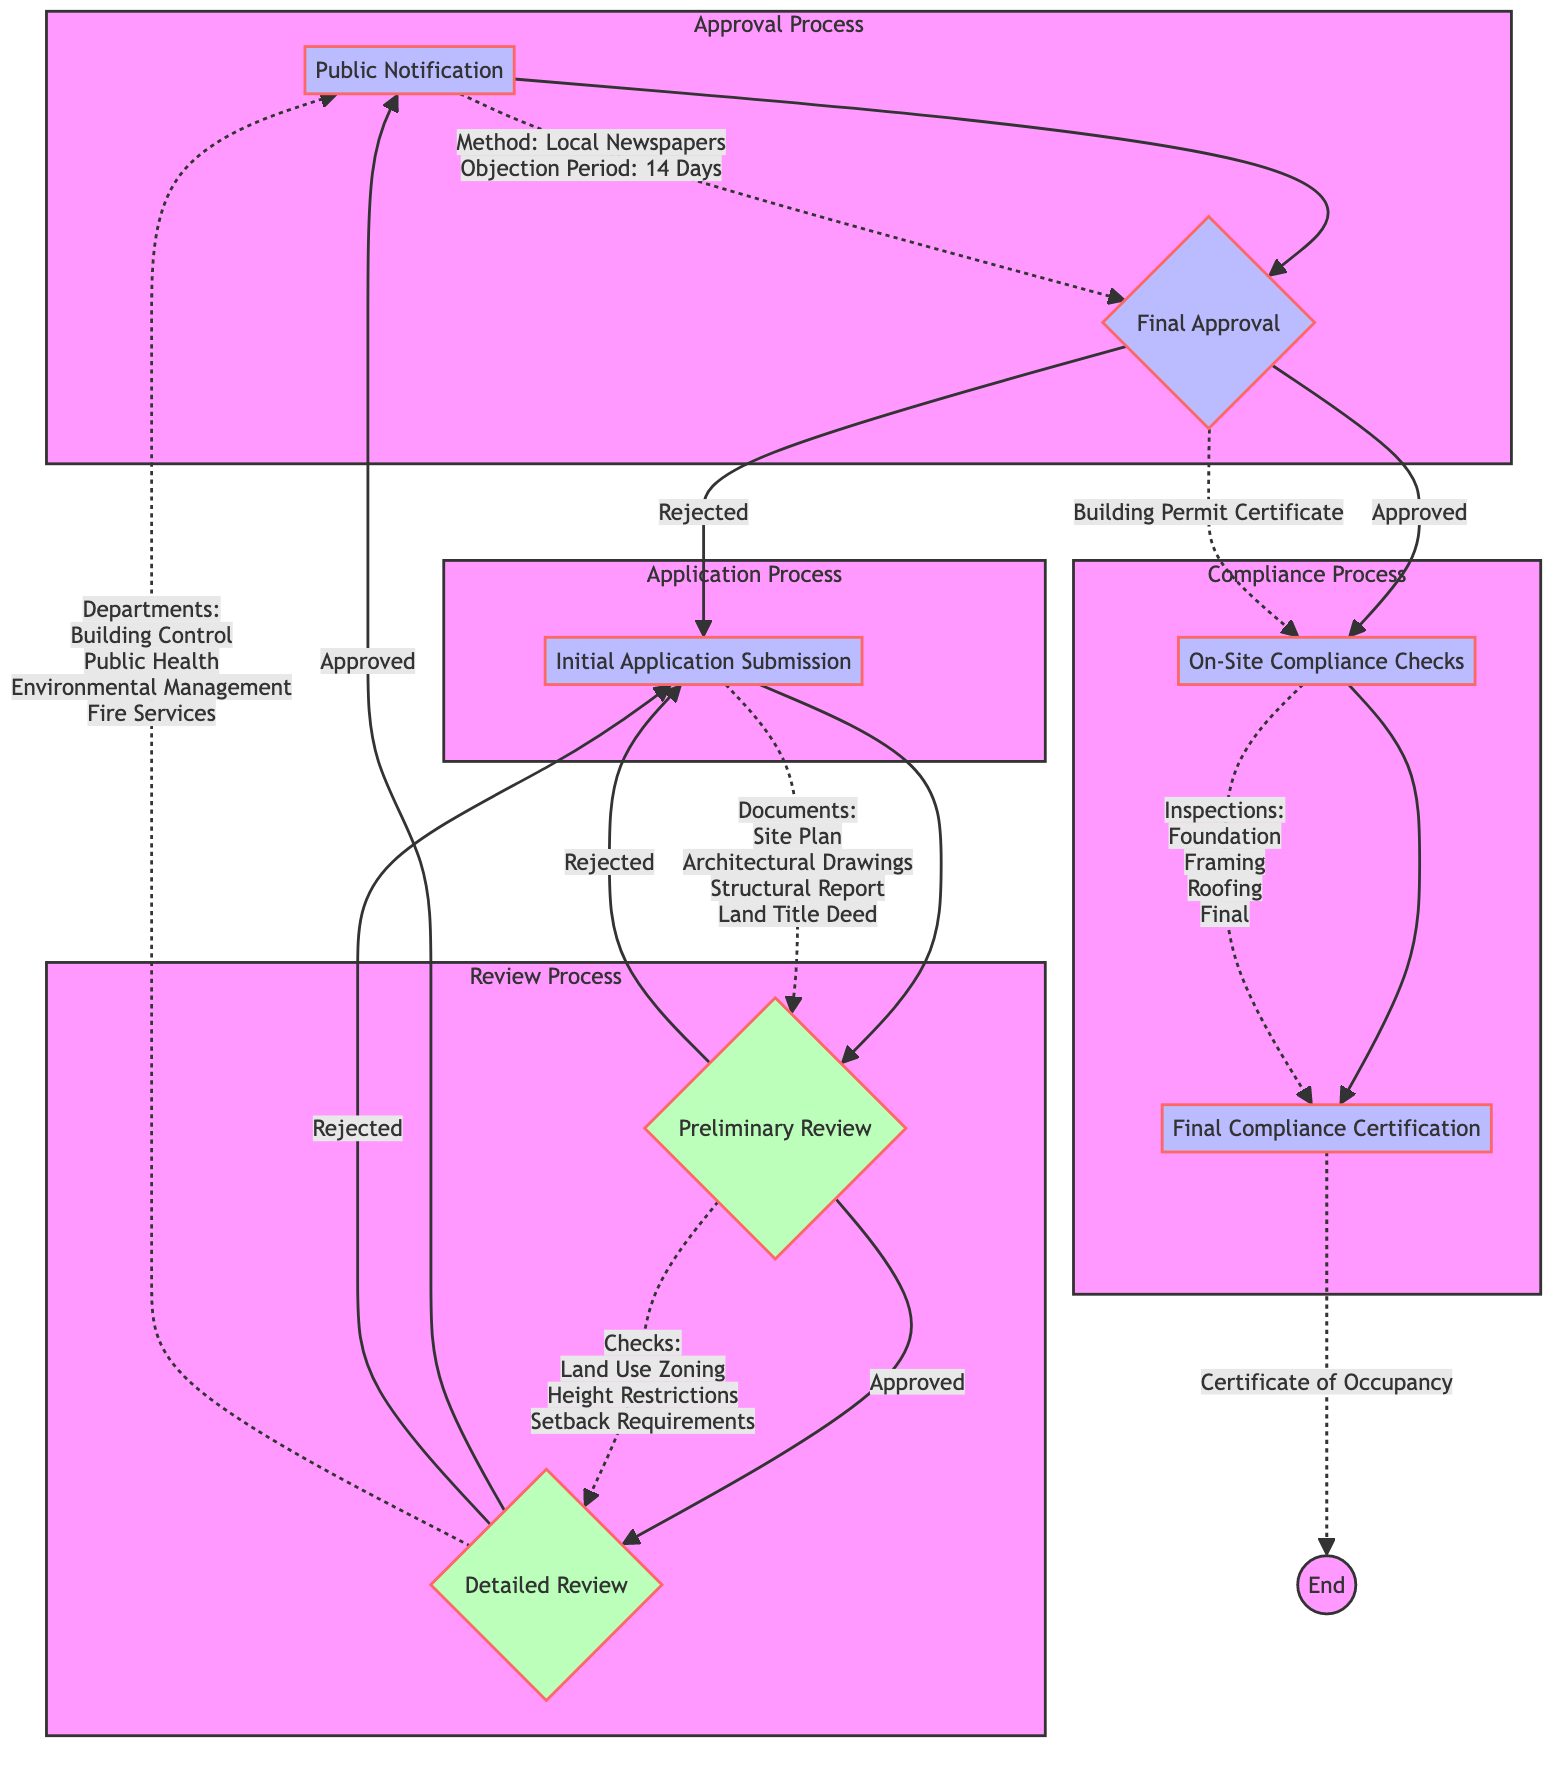What is the first step in the building permit approval process? The first step in the process is "Initial Application Submission," where the property owner or developer submits the required documents.
Answer: Initial Application Submission How many checks are performed during the Preliminary Review? The Preliminary Review includes three checks: Land Use Zoning, Building Height Restrictions, and Setback Requirements.
Answer: 3 Which department is responsible for the Detailed Review? The Detailed Review involves multiple departments: Building Control, Public Health, Environmental Management, and Fire Services.
Answer: Building Control, Public Health, Environmental Management, Fire Services What happens if the Detailed Review is rejected? If the Detailed Review is rejected, the process loops back to the "Initial Application Submission," where the applicant may need to revise their submission.
Answer: A What is the duration of the objection period during Public Notification? The objection period during Public Notification lasts for 14 days, giving the community time to raise any concerns or objections.
Answer: 14 Days What is issued after the Final Approval? After the Final Approval, a "Building Permit Certificate" is issued, allowing the applicant to proceed with their construction plans.
Answer: Building Permit Certificate Which inspections are included in the On-Site Compliance Checks? The On-Site Compliance Checks include inspections at four stages: Foundation, Framing, Roofing, and Final Inspection.
Answer: Foundation, Framing, Roofing, Final Inspection Who issues the Final Compliance Certification? The Final Compliance Certification, known as the "Certificate of Occupancy," is issued by the Municipal Council upon successful completion of compliance checks.
Answer: Municipal Council What is the method for Public Notification? The method used for Public Notification is through Local Newspapers and Public Notice Boards, ensuring the community is informed of the application.
Answer: Local Newspapers and Public Notice Boards 